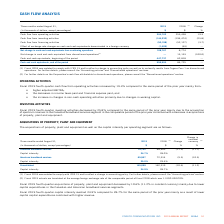According to Cogeco's financial document, What was the increase in the operating activities in fourth-quarter 2019? According to the financial document, 19.3%. The relevant text states: "r cash flow from operating activities increased by 19.3% compared to the same period of the prior year mainly from:..." Also, What was reason for the increase in changes in non-cash operating activities? primarily due to changes in working capital.. The document states: "crease in changes in non-cash operating activities primarily due to changes in working capital...." Also, What was the decrease in the investing activities in 2019? According to the financial document, 25.8%. The relevant text states: "9 fourth-quarter investing activities decreased by 25.8% compared to the same period of the prior year mainly due to the acquisition of spectrum licenses in..." Also, can you calculate: What was the increase / (decrease) in cash flow from operating activities from 2018 to 2019? Based on the calculation: 304,702 - 255,438, the result is 49264 (in thousands). This is based on the information: "Cash flow from operating activities 304,702 255,438 19.3 Cash flow from operating activities 304,702 255,438 19.3..." The key data points involved are: 255,438, 304,702. Also, can you calculate: What was the average Cash flow from investing activities? To answer this question, I need to perform calculations using the financial data. The calculation is: -(144,332 + 194,474) / 2, which equals -169403 (in thousands). This is based on the information: "Cash flow from investing activities (144,332) (194,474) (25.8) Cash flow from investing activities (144,332) (194,474) (25.8)..." The key data points involved are: 144,332, 194,474. Also, can you calculate: What was the average Cash flow from financing activities? To answer this question, I need to perform calculations using the financial data. The calculation is: -(50,198 + 52,127) / 2, which equals -51162.5 (in thousands). This is based on the information: "Cash flow from financing activities (50,198) (52,127) (3.7) Cash flow from financing activities (50,198) (52,127) (3.7)..." The key data points involved are: 50,198, 52,127. 